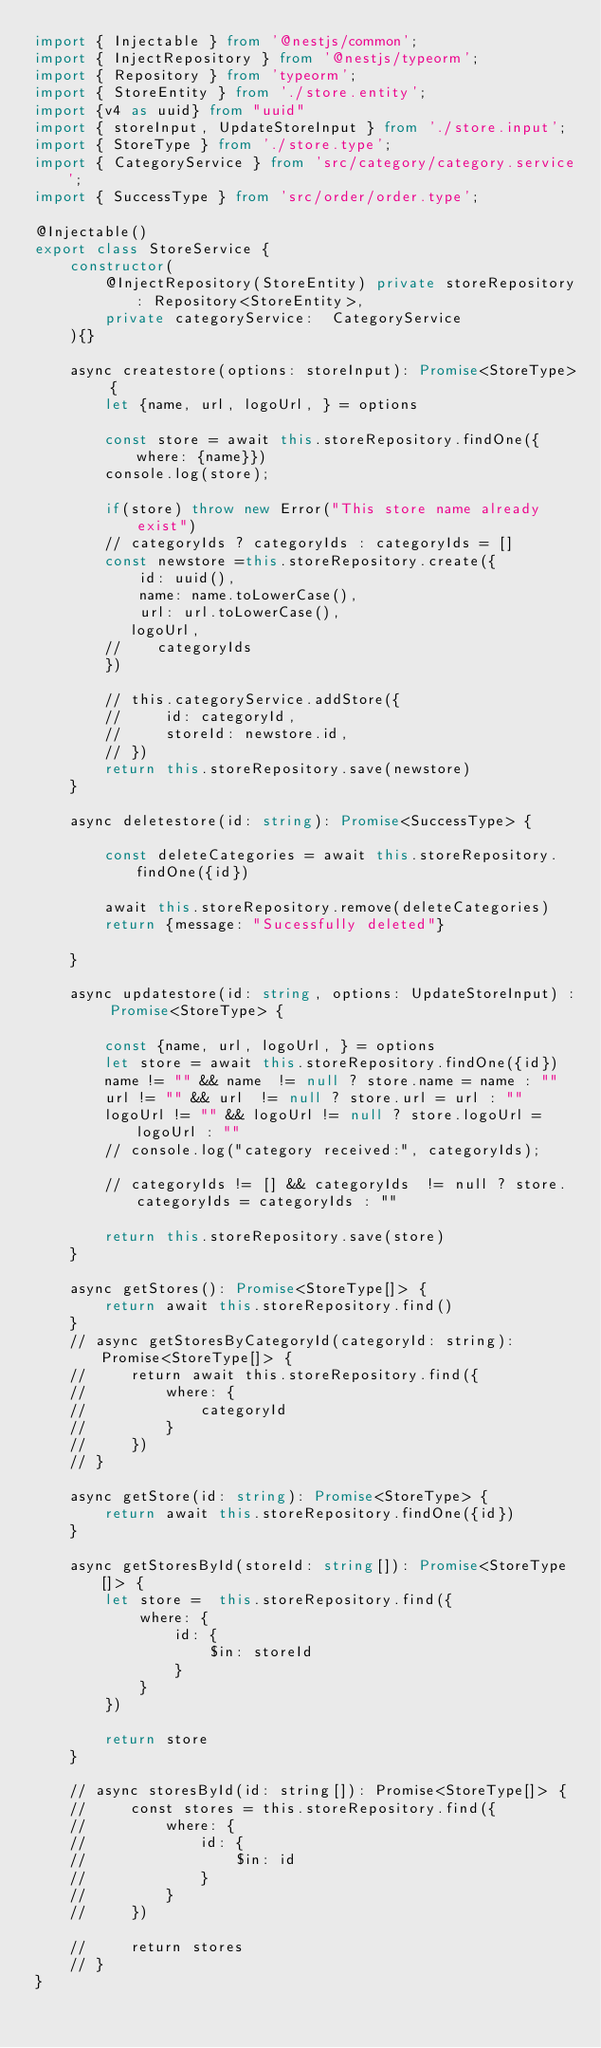Convert code to text. <code><loc_0><loc_0><loc_500><loc_500><_TypeScript_>import { Injectable } from '@nestjs/common';
import { InjectRepository } from '@nestjs/typeorm';
import { Repository } from 'typeorm';
import { StoreEntity } from './store.entity';
import {v4 as uuid} from "uuid"
import { storeInput, UpdateStoreInput } from './store.input';
import { StoreType } from './store.type';
import { CategoryService } from 'src/category/category.service';
import { SuccessType } from 'src/order/order.type';

@Injectable()
export class StoreService {
    constructor(
        @InjectRepository(StoreEntity) private storeRepository: Repository<StoreEntity>,
        private categoryService:  CategoryService
    ){}

    async createstore(options: storeInput): Promise<StoreType> {
        let {name, url, logoUrl, } = options
        
        const store = await this.storeRepository.findOne({where: {name}})
        console.log(store);
        
        if(store) throw new Error("This store name already exist")
        // categoryIds ? categoryIds : categoryIds = []
        const newstore =this.storeRepository.create({
            id: uuid(), 
            name: name.toLowerCase(),
            url: url.toLowerCase(),
           logoUrl,
        //    categoryIds
        })

        // this.categoryService.addStore({
        //     id: categoryId,
        //     storeId: newstore.id,
        // })
        return this.storeRepository.save(newstore)
    }

    async deletestore(id: string): Promise<SuccessType> {

        const deleteCategories = await this.storeRepository.findOne({id})

        await this.storeRepository.remove(deleteCategories)
        return {message: "Sucessfully deleted"}

    }

    async updatestore(id: string, options: UpdateStoreInput) : Promise<StoreType> {

        const {name, url, logoUrl, } = options
        let store = await this.storeRepository.findOne({id})
        name != "" && name  != null ? store.name = name : ""
        url != "" && url  != null ? store.url = url : ""
        logoUrl != "" && logoUrl != null ? store.logoUrl = logoUrl : ""
        // console.log("category received:", categoryIds);
        
        // categoryIds != [] && categoryIds  != null ? store.categoryIds = categoryIds : ""

        return this.storeRepository.save(store)
    }

    async getStores(): Promise<StoreType[]> {
        return await this.storeRepository.find()
    }
    // async getStoresByCategoryId(categoryId: string): Promise<StoreType[]> {
    //     return await this.storeRepository.find({
    //         where: {
    //             categoryId
    //         }
    //     })
    // }

    async getStore(id: string): Promise<StoreType> {
        return await this.storeRepository.findOne({id})
    }

    async getStoresById(storeId: string[]): Promise<StoreType[]> {
        let store =  this.storeRepository.find({
            where: {
                id: {
                    $in: storeId
                }
            }
        })

        return store
    }

    // async storesById(id: string[]): Promise<StoreType[]> {
    //     const stores = this.storeRepository.find({
    //         where: {
    //             id: {
    //                 $in: id
    //             }
    //         }
    //     })

    //     return stores
    // }
}
</code> 